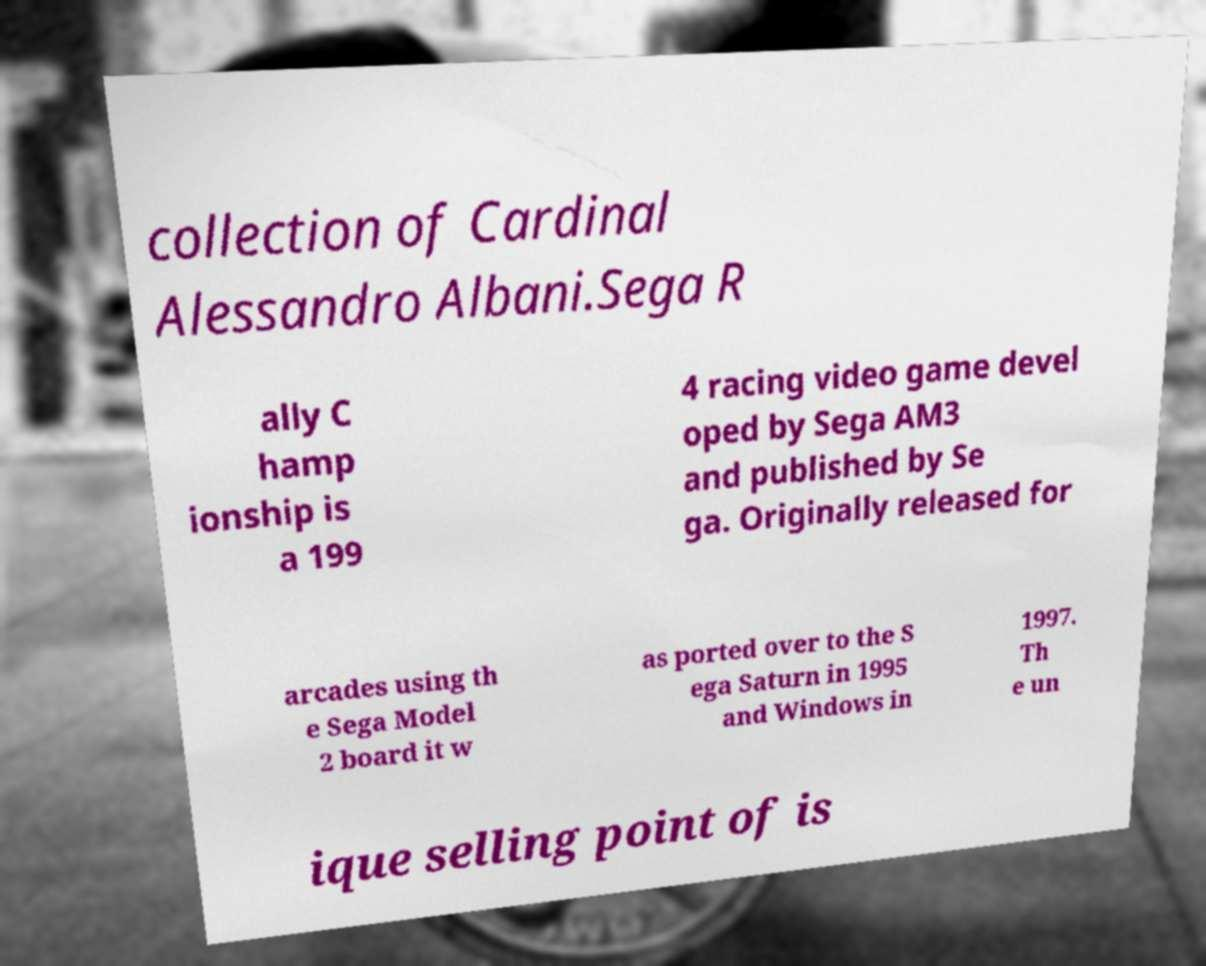There's text embedded in this image that I need extracted. Can you transcribe it verbatim? collection of Cardinal Alessandro Albani.Sega R ally C hamp ionship is a 199 4 racing video game devel oped by Sega AM3 and published by Se ga. Originally released for arcades using th e Sega Model 2 board it w as ported over to the S ega Saturn in 1995 and Windows in 1997. Th e un ique selling point of is 